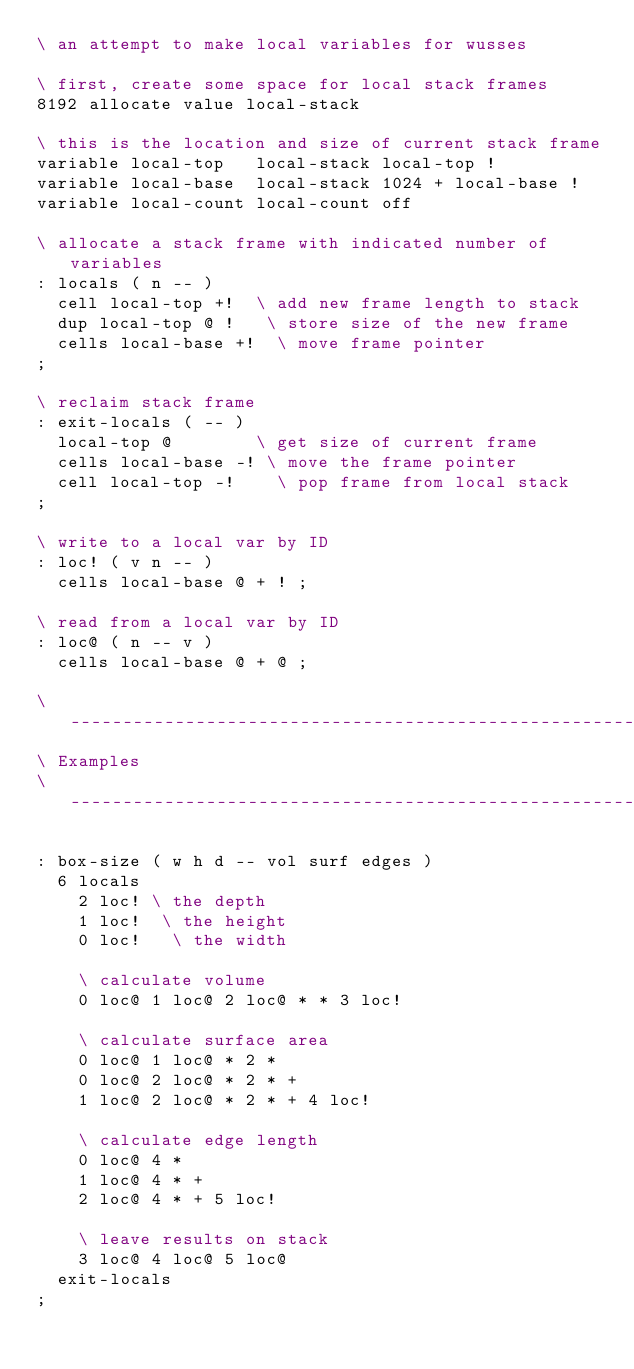Convert code to text. <code><loc_0><loc_0><loc_500><loc_500><_Forth_>\ an attempt to make local variables for wusses

\ first, create some space for local stack frames
8192 allocate value local-stack

\ this is the location and size of current stack frame
variable local-top   local-stack local-top !
variable local-base  local-stack 1024 + local-base !
variable local-count local-count off

\ allocate a stack frame with indicated number of variables
: locals ( n -- )
  cell local-top +!  \ add new frame length to stack
  dup local-top @ !   \ store size of the new frame
  cells local-base +!  \ move frame pointer
;

\ reclaim stack frame
: exit-locals ( -- )
  local-top @        \ get size of current frame
  cells local-base -! \ move the frame pointer
  cell local-top -!    \ pop frame from local stack
;

\ write to a local var by ID
: loc! ( v n -- )
  cells local-base @ + ! ;

\ read from a local var by ID
: loc@ ( n -- v )
  cells local-base @ + @ ;

\ ------------------------------------------------------------------------
\ Examples
\ ------------------------------------------------------------------------

: box-size ( w h d -- vol surf edges )
  6 locals
    2 loc! \ the depth
    1 loc!  \ the height
    0 loc!   \ the width

    \ calculate volume
    0 loc@ 1 loc@ 2 loc@ * * 3 loc!

    \ calculate surface area
    0 loc@ 1 loc@ * 2 *
    0 loc@ 2 loc@ * 2 * +
    1 loc@ 2 loc@ * 2 * + 4 loc!

    \ calculate edge length
    0 loc@ 4 *
    1 loc@ 4 * +
    2 loc@ 4 * + 5 loc!

    \ leave results on stack
    3 loc@ 4 loc@ 5 loc@
  exit-locals
;
</code> 